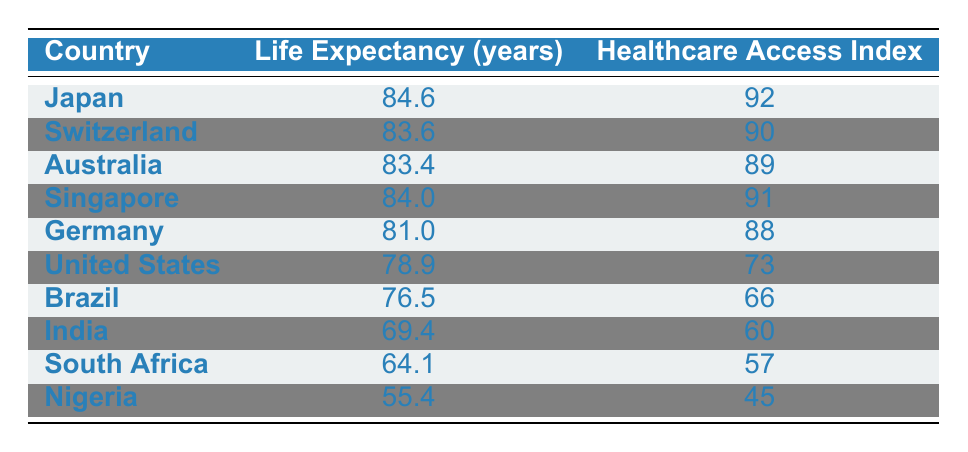What is the life expectancy for Japan? Japan's life expectancy is presented in the table. It can be found in the first row, specifically in the column labeled "Life Expectancy (years)."
Answer: 84.6 Which country has the highest healthcare access index? The healthcare access index is highest for Japan at 92. This can be found by comparing the values in the "Healthcare Access Index" column in the table.
Answer: Japan What is the average life expectancy of the countries listed? To find the average, add all life expectancy values: (84.6 + 83.6 + 83.4 + 84.0 + 81.0 + 78.9 + 76.5 + 69.4 + 64.1 + 55.4) =  807.9. Then divide by the number of countries, which is 10, resulting in an average of 807.9 / 10 = 80.79.
Answer: 80.79 Is the healthcare access index for South Africa greater than that of Nigeria? South Africa's healthcare access index is 57, while Nigeria’s is 45. Since 57 is greater than 45, the statement is true.
Answer: Yes If we compare Brazil and Germany, which country has a longer life expectancy and by how much? Brazil's life expectancy is 76.5 years, and Germany's is 81.0 years. To find the difference: 81.0 - 76.5 = 4.5 years. Germany has a longer life expectancy by 4.5 years.
Answer: Germany, 4.5 years What is the total life expectancy of all the countries listed? To find the total, add the life expectancy values for each country: (84.6 + 83.6 + 83.4 + 84.0 + 81.0 + 78.9 + 76.5 + 69.4 + 64.1 + 55.4) = 807.9. Thus, the total life expectancy is 807.9.
Answer: 807.9 Is it true that the life expectancy for the United States is below 80 years? The life expectancy for the United States is 78.9 years, which is indeed below 80 years. Therefore, the statement is true.
Answer: Yes What is the difference in life expectancy between Japan and South Africa? Japan has a life expectancy of 84.6 years, while South Africa has 64.1 years. To find the difference: 84.6 - 64.1 = 20.5 years.
Answer: 20.5 years 